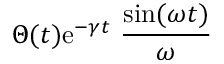Convert formula to latex. <formula><loc_0><loc_0><loc_500><loc_500>\Theta ( t ) e ^ { - \gamma t } { \frac { \sin ( \omega t ) } { \omega } }</formula> 